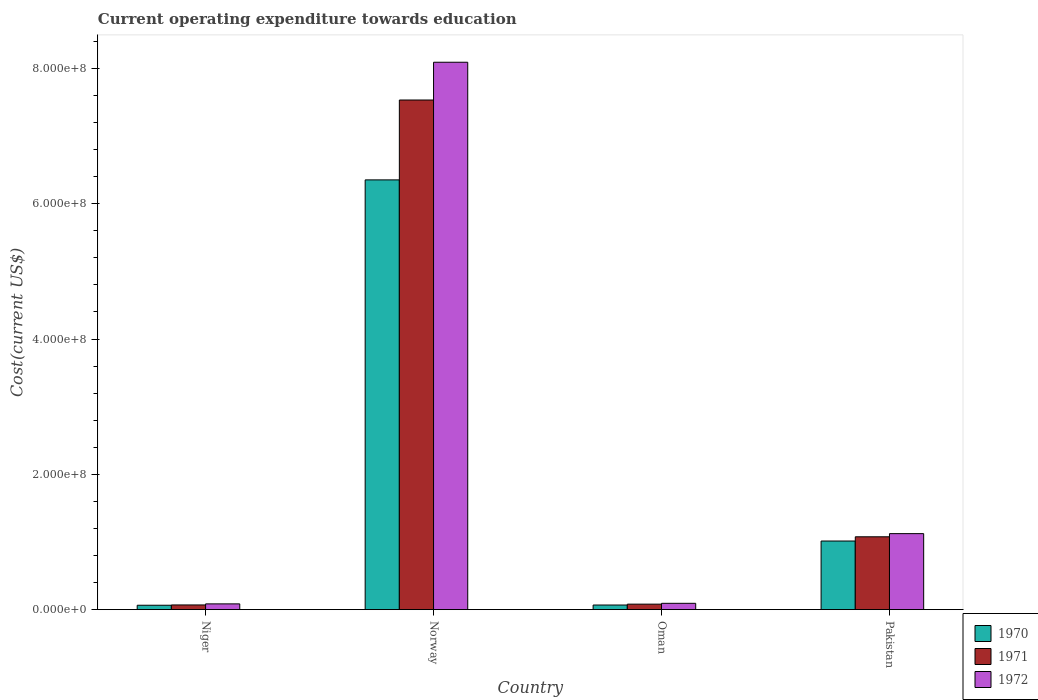How many different coloured bars are there?
Provide a short and direct response. 3. Are the number of bars per tick equal to the number of legend labels?
Provide a short and direct response. Yes. What is the label of the 3rd group of bars from the left?
Give a very brief answer. Oman. What is the expenditure towards education in 1970 in Oman?
Make the answer very short. 6.80e+06. Across all countries, what is the maximum expenditure towards education in 1971?
Ensure brevity in your answer.  7.53e+08. Across all countries, what is the minimum expenditure towards education in 1971?
Offer a very short reply. 6.92e+06. In which country was the expenditure towards education in 1970 minimum?
Your answer should be compact. Niger. What is the total expenditure towards education in 1972 in the graph?
Your response must be concise. 9.39e+08. What is the difference between the expenditure towards education in 1972 in Norway and that in Pakistan?
Offer a terse response. 6.97e+08. What is the difference between the expenditure towards education in 1971 in Pakistan and the expenditure towards education in 1972 in Norway?
Your answer should be compact. -7.02e+08. What is the average expenditure towards education in 1970 per country?
Your answer should be compact. 1.87e+08. What is the difference between the expenditure towards education of/in 1970 and expenditure towards education of/in 1972 in Niger?
Give a very brief answer. -2.01e+06. What is the ratio of the expenditure towards education in 1971 in Norway to that in Oman?
Give a very brief answer. 93.09. Is the difference between the expenditure towards education in 1970 in Norway and Pakistan greater than the difference between the expenditure towards education in 1972 in Norway and Pakistan?
Provide a short and direct response. No. What is the difference between the highest and the second highest expenditure towards education in 1970?
Keep it short and to the point. 9.46e+07. What is the difference between the highest and the lowest expenditure towards education in 1970?
Your response must be concise. 6.29e+08. In how many countries, is the expenditure towards education in 1970 greater than the average expenditure towards education in 1970 taken over all countries?
Ensure brevity in your answer.  1. What does the 3rd bar from the left in Pakistan represents?
Your answer should be compact. 1972. What does the 1st bar from the right in Niger represents?
Your response must be concise. 1972. Is it the case that in every country, the sum of the expenditure towards education in 1970 and expenditure towards education in 1972 is greater than the expenditure towards education in 1971?
Provide a short and direct response. Yes. How many bars are there?
Keep it short and to the point. 12. Are all the bars in the graph horizontal?
Provide a succinct answer. No. What is the difference between two consecutive major ticks on the Y-axis?
Keep it short and to the point. 2.00e+08. Where does the legend appear in the graph?
Offer a terse response. Bottom right. What is the title of the graph?
Your answer should be very brief. Current operating expenditure towards education. What is the label or title of the X-axis?
Give a very brief answer. Country. What is the label or title of the Y-axis?
Keep it short and to the point. Cost(current US$). What is the Cost(current US$) of 1970 in Niger?
Ensure brevity in your answer.  6.48e+06. What is the Cost(current US$) in 1971 in Niger?
Your answer should be very brief. 6.92e+06. What is the Cost(current US$) in 1972 in Niger?
Ensure brevity in your answer.  8.50e+06. What is the Cost(current US$) of 1970 in Norway?
Your answer should be compact. 6.35e+08. What is the Cost(current US$) of 1971 in Norway?
Your answer should be very brief. 7.53e+08. What is the Cost(current US$) of 1972 in Norway?
Provide a short and direct response. 8.09e+08. What is the Cost(current US$) in 1970 in Oman?
Your response must be concise. 6.80e+06. What is the Cost(current US$) of 1971 in Oman?
Your answer should be very brief. 8.09e+06. What is the Cost(current US$) in 1972 in Oman?
Keep it short and to the point. 9.32e+06. What is the Cost(current US$) of 1970 in Pakistan?
Your response must be concise. 1.01e+08. What is the Cost(current US$) in 1971 in Pakistan?
Your answer should be compact. 1.08e+08. What is the Cost(current US$) of 1972 in Pakistan?
Provide a short and direct response. 1.12e+08. Across all countries, what is the maximum Cost(current US$) in 1970?
Give a very brief answer. 6.35e+08. Across all countries, what is the maximum Cost(current US$) in 1971?
Offer a very short reply. 7.53e+08. Across all countries, what is the maximum Cost(current US$) in 1972?
Keep it short and to the point. 8.09e+08. Across all countries, what is the minimum Cost(current US$) of 1970?
Ensure brevity in your answer.  6.48e+06. Across all countries, what is the minimum Cost(current US$) in 1971?
Your response must be concise. 6.92e+06. Across all countries, what is the minimum Cost(current US$) in 1972?
Ensure brevity in your answer.  8.50e+06. What is the total Cost(current US$) in 1970 in the graph?
Your answer should be compact. 7.50e+08. What is the total Cost(current US$) in 1971 in the graph?
Keep it short and to the point. 8.76e+08. What is the total Cost(current US$) in 1972 in the graph?
Your answer should be compact. 9.39e+08. What is the difference between the Cost(current US$) in 1970 in Niger and that in Norway?
Provide a succinct answer. -6.29e+08. What is the difference between the Cost(current US$) in 1971 in Niger and that in Norway?
Provide a succinct answer. -7.46e+08. What is the difference between the Cost(current US$) of 1972 in Niger and that in Norway?
Provide a succinct answer. -8.01e+08. What is the difference between the Cost(current US$) of 1970 in Niger and that in Oman?
Provide a short and direct response. -3.20e+05. What is the difference between the Cost(current US$) in 1971 in Niger and that in Oman?
Ensure brevity in your answer.  -1.17e+06. What is the difference between the Cost(current US$) in 1972 in Niger and that in Oman?
Your response must be concise. -8.26e+05. What is the difference between the Cost(current US$) of 1970 in Niger and that in Pakistan?
Make the answer very short. -9.49e+07. What is the difference between the Cost(current US$) in 1971 in Niger and that in Pakistan?
Your response must be concise. -1.01e+08. What is the difference between the Cost(current US$) of 1972 in Niger and that in Pakistan?
Your response must be concise. -1.04e+08. What is the difference between the Cost(current US$) of 1970 in Norway and that in Oman?
Your answer should be very brief. 6.28e+08. What is the difference between the Cost(current US$) in 1971 in Norway and that in Oman?
Keep it short and to the point. 7.45e+08. What is the difference between the Cost(current US$) of 1972 in Norway and that in Oman?
Your answer should be very brief. 8.00e+08. What is the difference between the Cost(current US$) of 1970 in Norway and that in Pakistan?
Your answer should be very brief. 5.34e+08. What is the difference between the Cost(current US$) in 1971 in Norway and that in Pakistan?
Provide a succinct answer. 6.46e+08. What is the difference between the Cost(current US$) in 1972 in Norway and that in Pakistan?
Your answer should be compact. 6.97e+08. What is the difference between the Cost(current US$) of 1970 in Oman and that in Pakistan?
Make the answer very short. -9.46e+07. What is the difference between the Cost(current US$) in 1971 in Oman and that in Pakistan?
Provide a succinct answer. -9.96e+07. What is the difference between the Cost(current US$) in 1972 in Oman and that in Pakistan?
Keep it short and to the point. -1.03e+08. What is the difference between the Cost(current US$) in 1970 in Niger and the Cost(current US$) in 1971 in Norway?
Your response must be concise. -7.47e+08. What is the difference between the Cost(current US$) of 1970 in Niger and the Cost(current US$) of 1972 in Norway?
Your answer should be compact. -8.03e+08. What is the difference between the Cost(current US$) in 1971 in Niger and the Cost(current US$) in 1972 in Norway?
Offer a very short reply. -8.02e+08. What is the difference between the Cost(current US$) of 1970 in Niger and the Cost(current US$) of 1971 in Oman?
Make the answer very short. -1.61e+06. What is the difference between the Cost(current US$) in 1970 in Niger and the Cost(current US$) in 1972 in Oman?
Offer a terse response. -2.84e+06. What is the difference between the Cost(current US$) in 1971 in Niger and the Cost(current US$) in 1972 in Oman?
Keep it short and to the point. -2.40e+06. What is the difference between the Cost(current US$) in 1970 in Niger and the Cost(current US$) in 1971 in Pakistan?
Make the answer very short. -1.01e+08. What is the difference between the Cost(current US$) of 1970 in Niger and the Cost(current US$) of 1972 in Pakistan?
Ensure brevity in your answer.  -1.06e+08. What is the difference between the Cost(current US$) in 1971 in Niger and the Cost(current US$) in 1972 in Pakistan?
Make the answer very short. -1.05e+08. What is the difference between the Cost(current US$) of 1970 in Norway and the Cost(current US$) of 1971 in Oman?
Give a very brief answer. 6.27e+08. What is the difference between the Cost(current US$) in 1970 in Norway and the Cost(current US$) in 1972 in Oman?
Make the answer very short. 6.26e+08. What is the difference between the Cost(current US$) of 1971 in Norway and the Cost(current US$) of 1972 in Oman?
Give a very brief answer. 7.44e+08. What is the difference between the Cost(current US$) in 1970 in Norway and the Cost(current US$) in 1971 in Pakistan?
Offer a very short reply. 5.28e+08. What is the difference between the Cost(current US$) of 1970 in Norway and the Cost(current US$) of 1972 in Pakistan?
Offer a terse response. 5.23e+08. What is the difference between the Cost(current US$) of 1971 in Norway and the Cost(current US$) of 1972 in Pakistan?
Offer a very short reply. 6.41e+08. What is the difference between the Cost(current US$) of 1970 in Oman and the Cost(current US$) of 1971 in Pakistan?
Your answer should be compact. -1.01e+08. What is the difference between the Cost(current US$) in 1970 in Oman and the Cost(current US$) in 1972 in Pakistan?
Offer a terse response. -1.06e+08. What is the difference between the Cost(current US$) in 1971 in Oman and the Cost(current US$) in 1972 in Pakistan?
Your response must be concise. -1.04e+08. What is the average Cost(current US$) in 1970 per country?
Give a very brief answer. 1.87e+08. What is the average Cost(current US$) of 1971 per country?
Your answer should be very brief. 2.19e+08. What is the average Cost(current US$) in 1972 per country?
Offer a very short reply. 2.35e+08. What is the difference between the Cost(current US$) of 1970 and Cost(current US$) of 1971 in Niger?
Your answer should be very brief. -4.39e+05. What is the difference between the Cost(current US$) in 1970 and Cost(current US$) in 1972 in Niger?
Provide a succinct answer. -2.01e+06. What is the difference between the Cost(current US$) in 1971 and Cost(current US$) in 1972 in Niger?
Keep it short and to the point. -1.57e+06. What is the difference between the Cost(current US$) in 1970 and Cost(current US$) in 1971 in Norway?
Your answer should be compact. -1.18e+08. What is the difference between the Cost(current US$) of 1970 and Cost(current US$) of 1972 in Norway?
Provide a succinct answer. -1.74e+08. What is the difference between the Cost(current US$) in 1971 and Cost(current US$) in 1972 in Norway?
Offer a very short reply. -5.58e+07. What is the difference between the Cost(current US$) in 1970 and Cost(current US$) in 1971 in Oman?
Ensure brevity in your answer.  -1.29e+06. What is the difference between the Cost(current US$) of 1970 and Cost(current US$) of 1972 in Oman?
Your response must be concise. -2.52e+06. What is the difference between the Cost(current US$) in 1971 and Cost(current US$) in 1972 in Oman?
Make the answer very short. -1.23e+06. What is the difference between the Cost(current US$) in 1970 and Cost(current US$) in 1971 in Pakistan?
Your answer should be very brief. -6.25e+06. What is the difference between the Cost(current US$) in 1970 and Cost(current US$) in 1972 in Pakistan?
Keep it short and to the point. -1.09e+07. What is the difference between the Cost(current US$) of 1971 and Cost(current US$) of 1972 in Pakistan?
Your answer should be very brief. -4.68e+06. What is the ratio of the Cost(current US$) in 1970 in Niger to that in Norway?
Provide a short and direct response. 0.01. What is the ratio of the Cost(current US$) in 1971 in Niger to that in Norway?
Keep it short and to the point. 0.01. What is the ratio of the Cost(current US$) of 1972 in Niger to that in Norway?
Offer a very short reply. 0.01. What is the ratio of the Cost(current US$) of 1970 in Niger to that in Oman?
Your answer should be very brief. 0.95. What is the ratio of the Cost(current US$) in 1971 in Niger to that in Oman?
Provide a short and direct response. 0.86. What is the ratio of the Cost(current US$) of 1972 in Niger to that in Oman?
Provide a short and direct response. 0.91. What is the ratio of the Cost(current US$) of 1970 in Niger to that in Pakistan?
Keep it short and to the point. 0.06. What is the ratio of the Cost(current US$) in 1971 in Niger to that in Pakistan?
Provide a succinct answer. 0.06. What is the ratio of the Cost(current US$) of 1972 in Niger to that in Pakistan?
Provide a short and direct response. 0.08. What is the ratio of the Cost(current US$) in 1970 in Norway to that in Oman?
Provide a short and direct response. 93.36. What is the ratio of the Cost(current US$) of 1971 in Norway to that in Oman?
Offer a terse response. 93.09. What is the ratio of the Cost(current US$) of 1972 in Norway to that in Oman?
Your answer should be very brief. 86.8. What is the ratio of the Cost(current US$) in 1970 in Norway to that in Pakistan?
Your response must be concise. 6.26. What is the ratio of the Cost(current US$) of 1971 in Norway to that in Pakistan?
Provide a succinct answer. 7. What is the ratio of the Cost(current US$) of 1972 in Norway to that in Pakistan?
Provide a short and direct response. 7.2. What is the ratio of the Cost(current US$) of 1970 in Oman to that in Pakistan?
Your answer should be compact. 0.07. What is the ratio of the Cost(current US$) of 1971 in Oman to that in Pakistan?
Keep it short and to the point. 0.08. What is the ratio of the Cost(current US$) of 1972 in Oman to that in Pakistan?
Provide a short and direct response. 0.08. What is the difference between the highest and the second highest Cost(current US$) of 1970?
Offer a very short reply. 5.34e+08. What is the difference between the highest and the second highest Cost(current US$) of 1971?
Keep it short and to the point. 6.46e+08. What is the difference between the highest and the second highest Cost(current US$) of 1972?
Provide a short and direct response. 6.97e+08. What is the difference between the highest and the lowest Cost(current US$) in 1970?
Your answer should be very brief. 6.29e+08. What is the difference between the highest and the lowest Cost(current US$) in 1971?
Provide a short and direct response. 7.46e+08. What is the difference between the highest and the lowest Cost(current US$) in 1972?
Keep it short and to the point. 8.01e+08. 